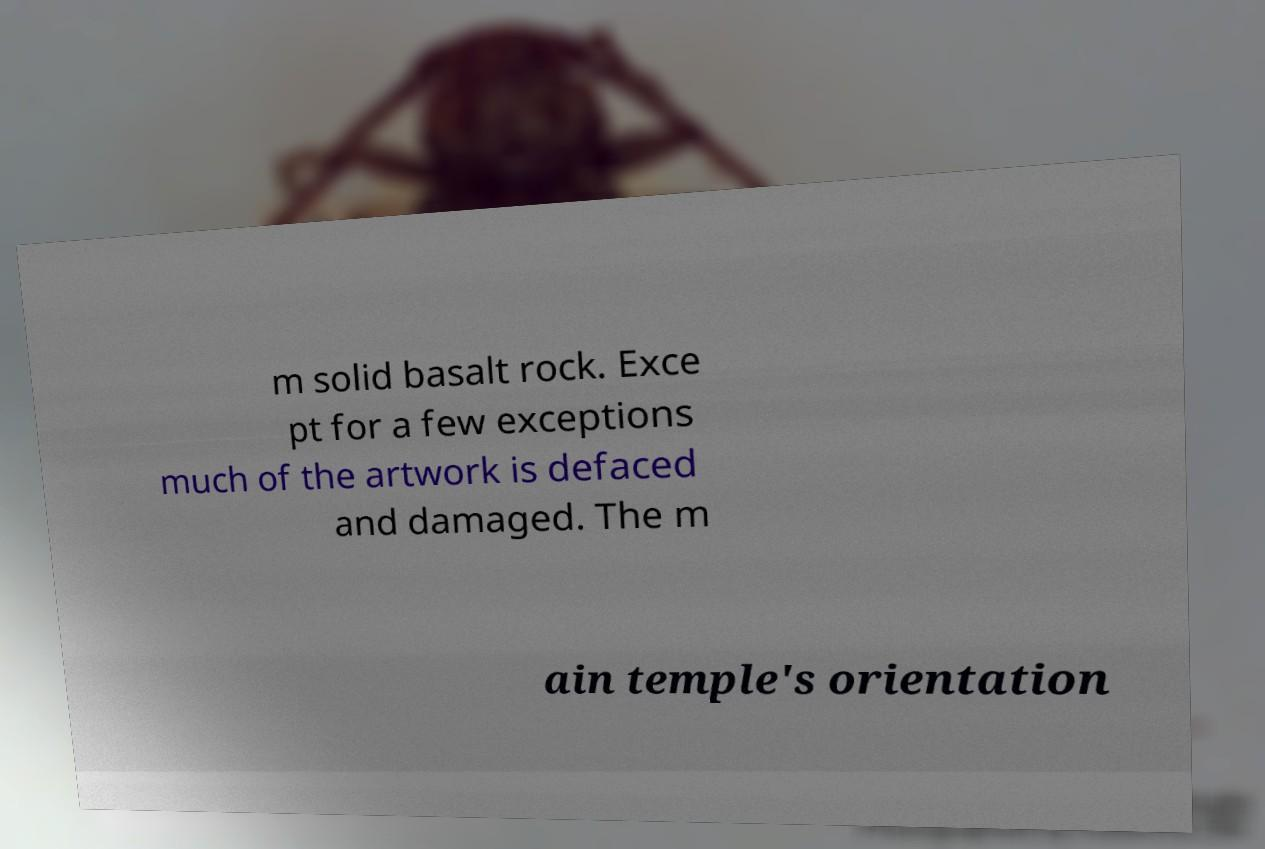Can you accurately transcribe the text from the provided image for me? m solid basalt rock. Exce pt for a few exceptions much of the artwork is defaced and damaged. The m ain temple's orientation 